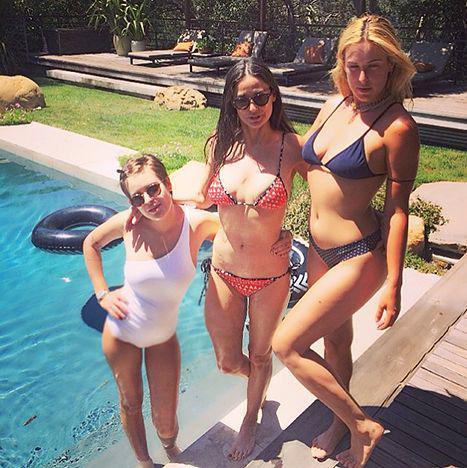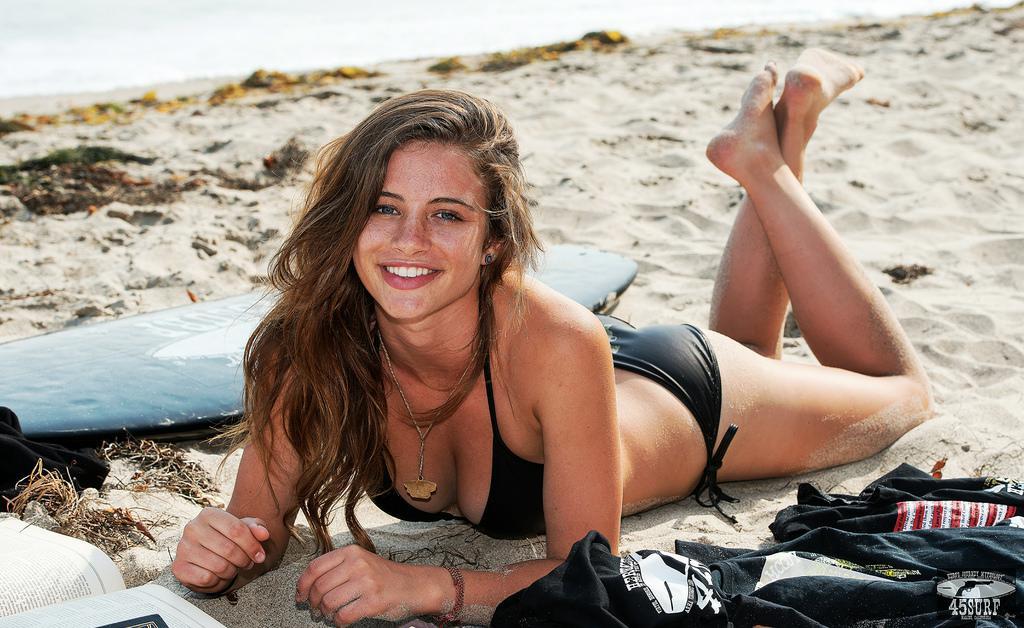The first image is the image on the left, the second image is the image on the right. Given the left and right images, does the statement "A woman is wearing a red polka dot swimsuit." hold true? Answer yes or no. Yes. The first image is the image on the left, the second image is the image on the right. Given the left and right images, does the statement "An image shows a trio of swimwear models, with at least one wearing a one-piece suit." hold true? Answer yes or no. Yes. 